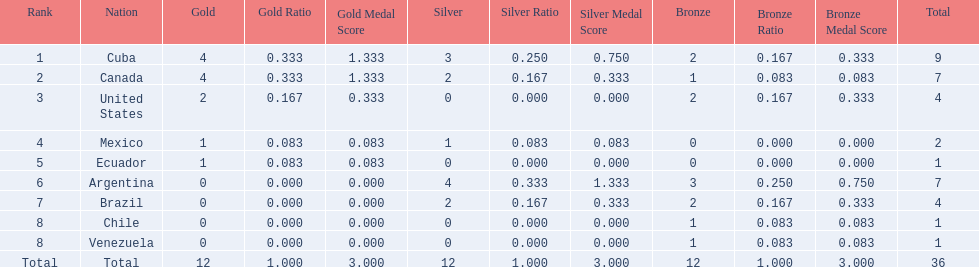Which nations won a gold medal in canoeing in the 2011 pan american games? Cuba, Canada, United States, Mexico, Ecuador. Which of these did not win any silver medals? United States. 